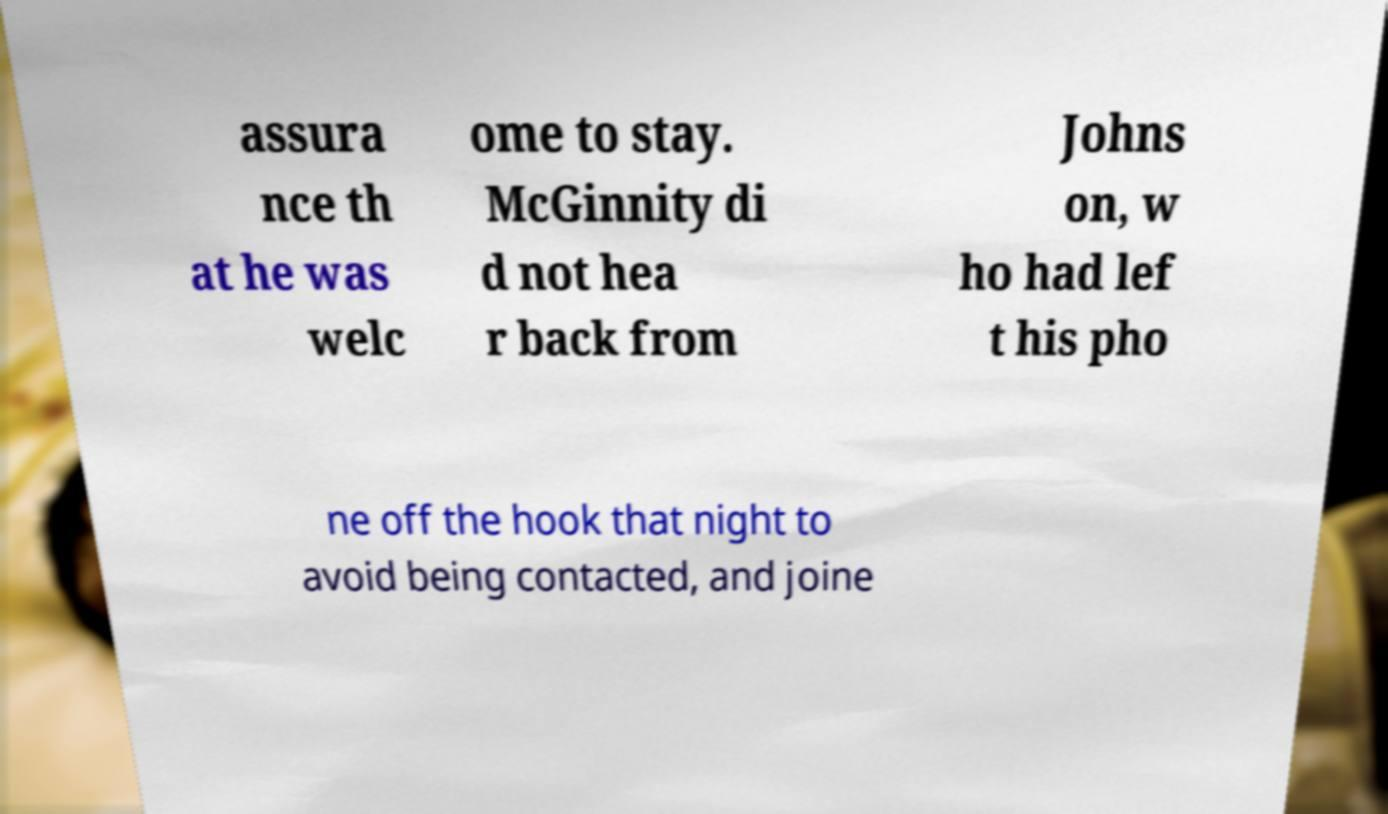There's text embedded in this image that I need extracted. Can you transcribe it verbatim? assura nce th at he was welc ome to stay. McGinnity di d not hea r back from Johns on, w ho had lef t his pho ne off the hook that night to avoid being contacted, and joine 